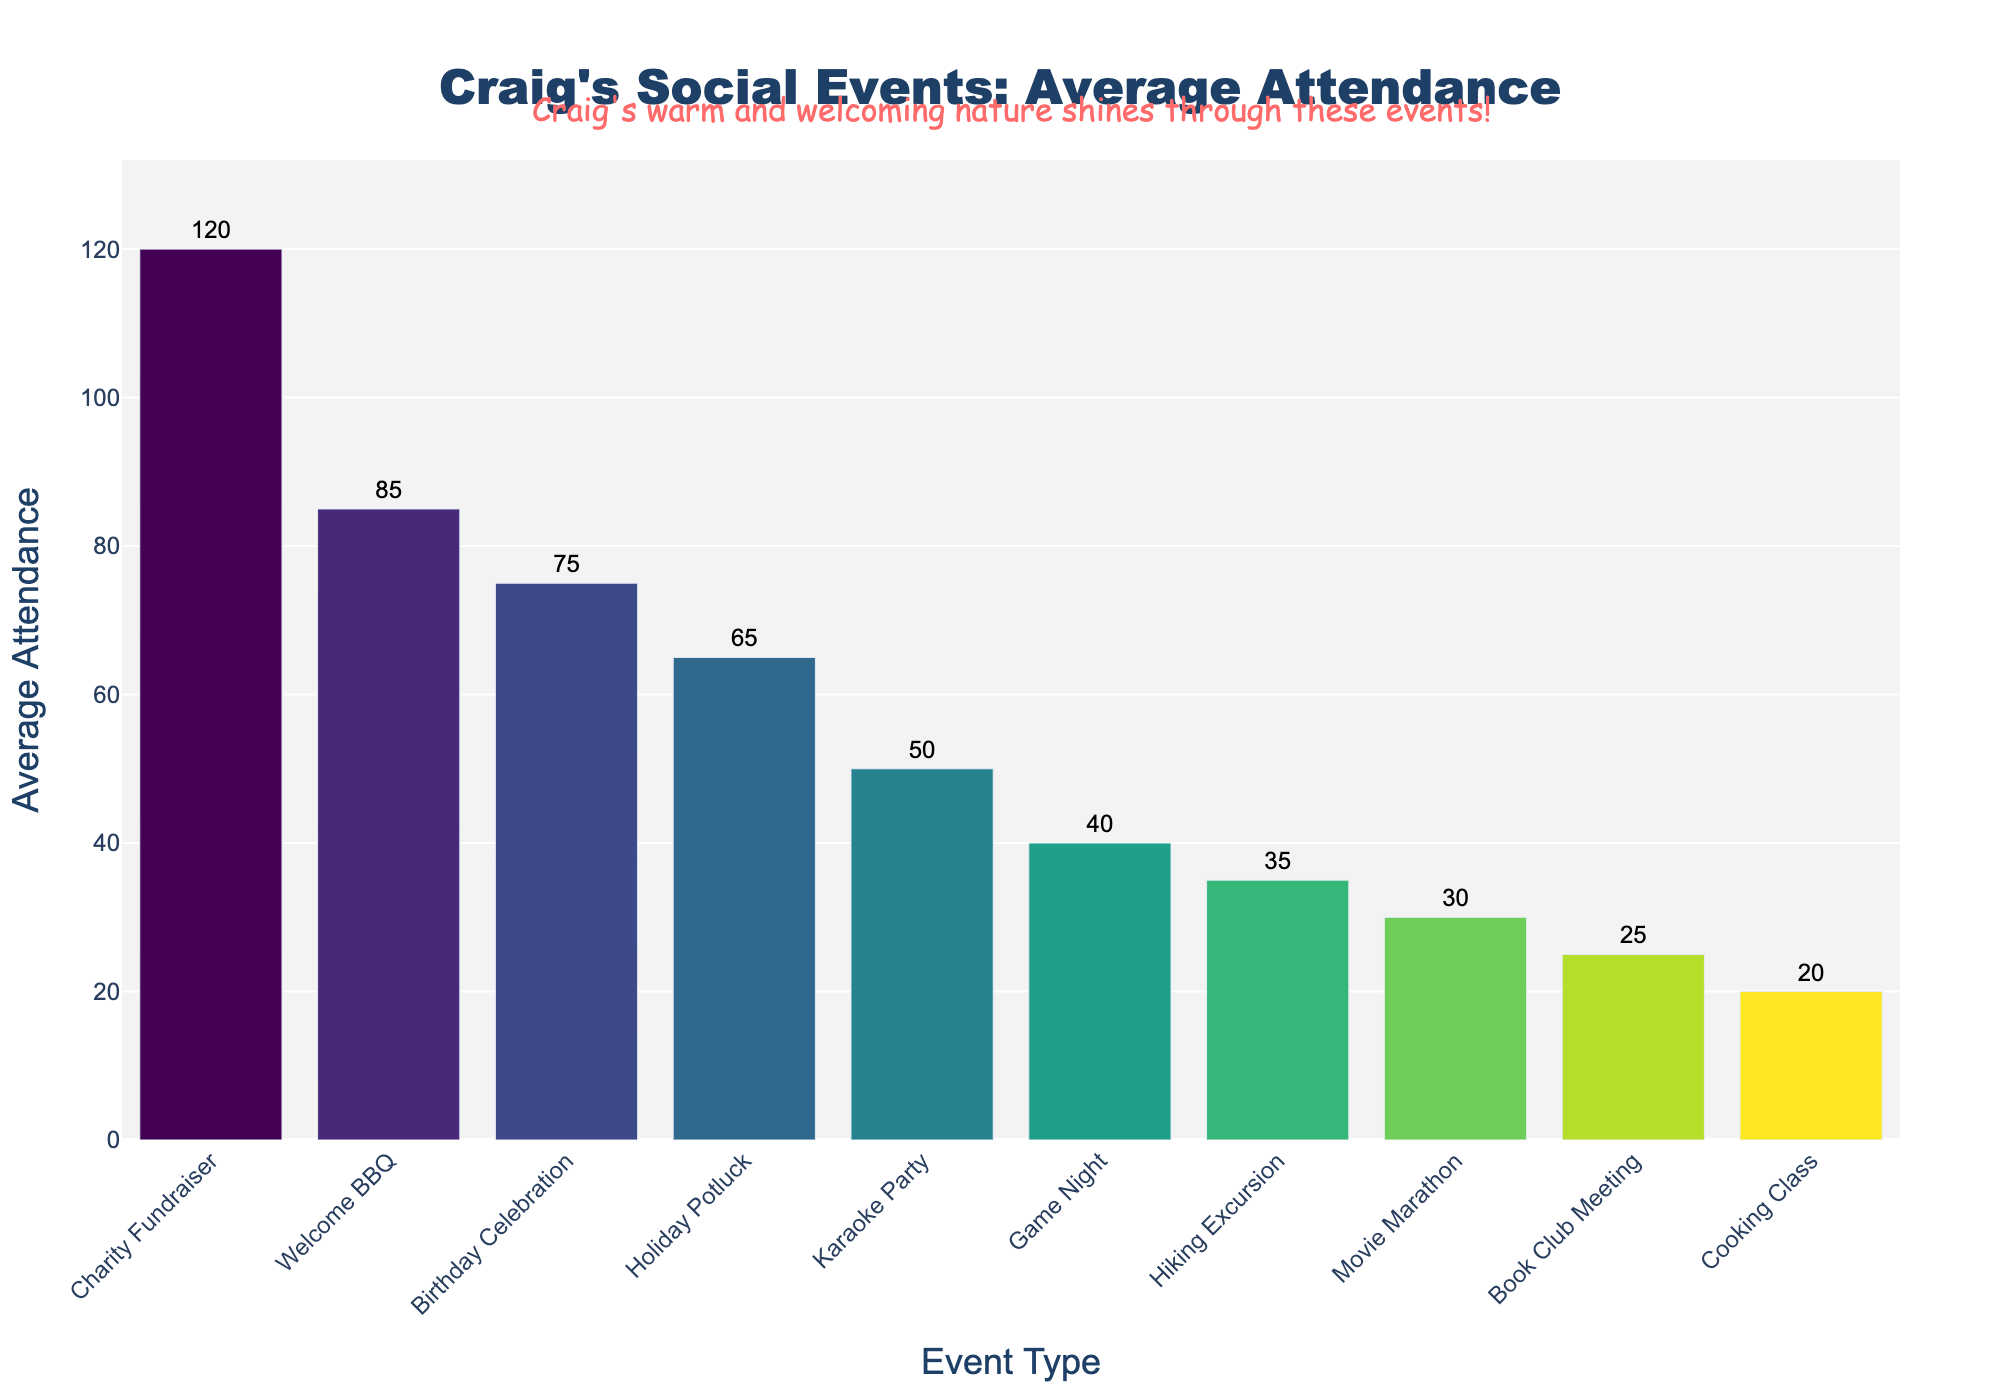What's the event with the highest average attendance? The tallest bar represents the event with the highest average attendance, which is 'Charity Fundraiser' with an attendance of 120.
Answer: Charity Fundraiser Which event has a higher average attendance: Game Night or Karaoke Party? Compare the height of the bars for 'Game Night' and 'Karaoke Party'. 'Karaoke Party' has an average attendance of 50, which is higher than 'Game Night's' 40.
Answer: Karaoke Party What's the total average attendance for Welcome BBQ and Birthday Celebration? Add the average attendance for 'Welcome BBQ' (85) and 'Birthday Celebration' (75): 85 + 75 = 160.
Answer: 160 Which event has the lowest average attendance? The shortest bar represents the event with the lowest average attendance, which is 'Cooking Class' with an attendance of 20.
Answer: Cooking Class Is the average attendance for Book Club Meeting greater than Hiking Excursion? Compare the heights of the bars for 'Book Club Meeting' (25) and 'Hiking Excursion' (35). 'Hiking Excursion' has a higher average attendance.
Answer: No What's the common color scheme used in the chart? The bars in the chart use a gradient from the Viridis colormap, which transitions from dark blue to yellow-green.
Answer: Viridis gradient What's the difference in average attendance between the Holiday Potluck and Movie Marathon? Subtract the average attendance of 'Movie Marathon' (30) from 'Holiday Potluck' (65): 65 - 30 = 35.
Answer: 35 List events with an average attendance above 60. Identify the events with bars taller than 60: 'Welcome BBQ' (85), 'Holiday Potluck' (65), 'Charity Fundraiser' (120), and 'Birthday Celebration' (75).
Answer: Welcome BBQ, Holiday Potluck, Charity Fundraiser, Birthday Celebration What's the median average attendance of all events? List all attendance values in ascending order: 20, 25, 30, 35, 40, 50, 65, 75, 85, 120. The middle values are 50 and 65, so the median is (50 + 65) / 2 = 57.5.
Answer: 57.5 